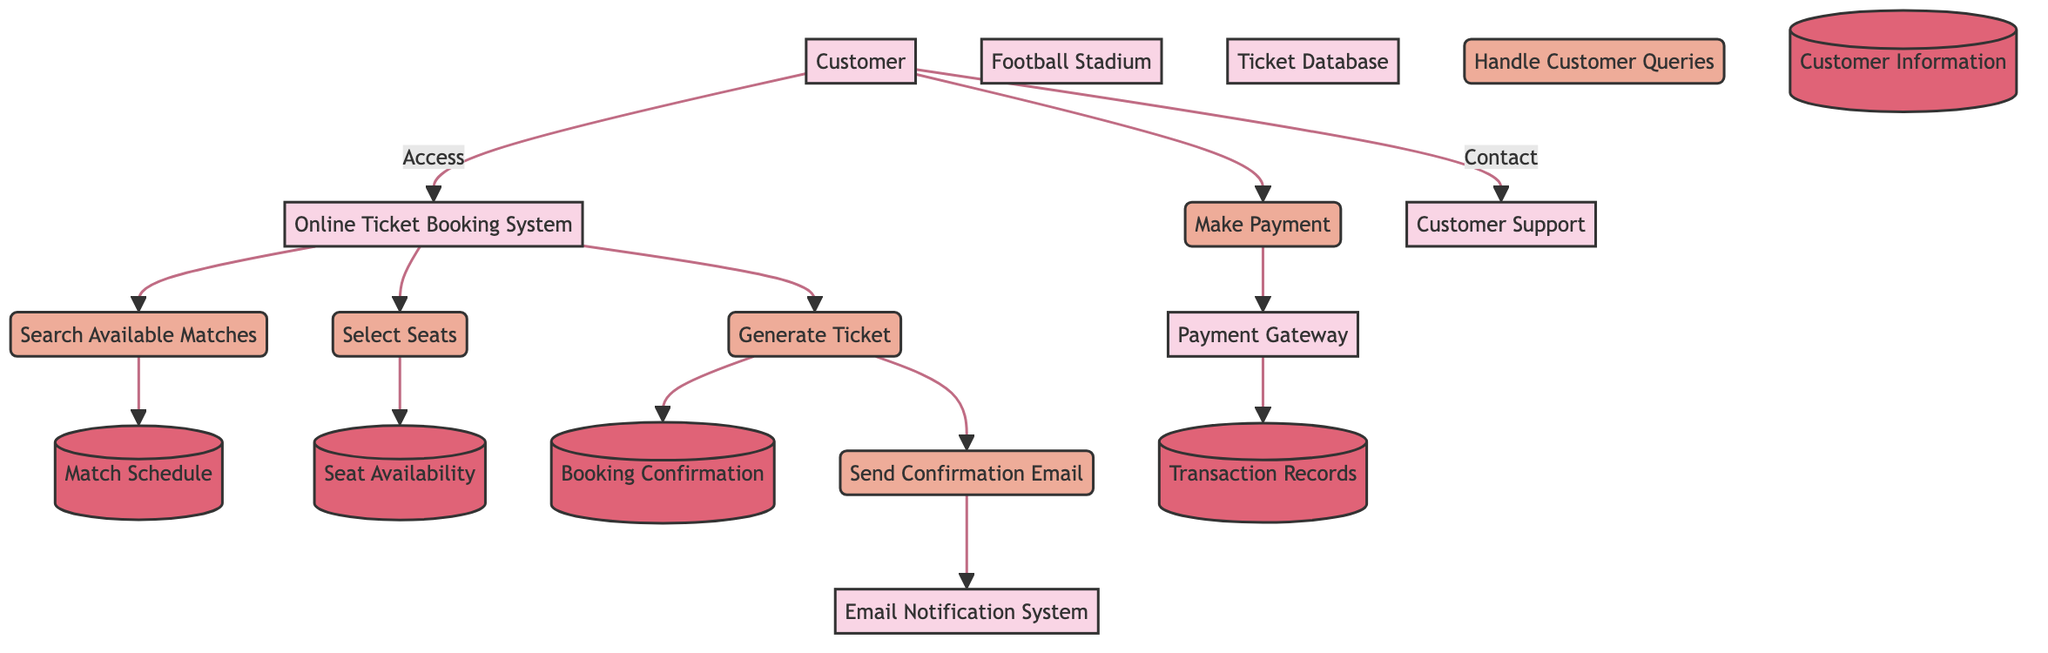What entity initiates the ticket booking process? The diagram shows that the Customer is the first entity that accesses the Online Ticket Booking System to start the ticket booking process.
Answer: Customer How many processes are involved in the ticket booking system? By counting the processes listed in the diagram, there are a total of six processes: Search Available Matches, Select Seats, Make Payment, Generate Ticket, Send Confirmation Email, and Handle Customer Queries.
Answer: 6 What data store holds the match schedule? The diagram indicates that the Match Schedule is a data store that contains the schedule of football matches, making it clear that it holds this specific information.
Answer: Match Schedule After making a payment, what is generated next? Following the flow of the diagram, after the payment is made and sent to the Payment Gateway, the next step is to Generate Ticket, which takes place after the payment is processed.
Answer: Generate Ticket Which system sends the booking confirmation email? The Email Notification System is the designated entity that sends the booking confirmation email, as shown in the flow from the Generate Ticket process to the Email Notification System.
Answer: Email Notification System What data flow occurs after selecting seats? The data flow after selecting seats moves from the Online Ticket Booking System to the Seat Availability data store to retrieve information about available seats for the selected match.
Answer: Retrieve available seats What action does the Customer take to resolve queries? The Customer contacts Customer Support for any queries or issues, as indicated by the arrow that illustrates the flow from the Customer to the Customer Support system.
Answer: Contact support How many data stores are present in the diagram? By reviewing the diagram, there are a total of five data stores: Match Schedule, Seat Availability, Customer Information, Transaction Records, and Booking Confirmation.
Answer: 5 What process follows after the transactional details are stored? The process that follows after the Payment Gateway stores the transaction details in Transaction Records is the Generate Ticket process, which creates the digital ticket.
Answer: Generate Ticket 